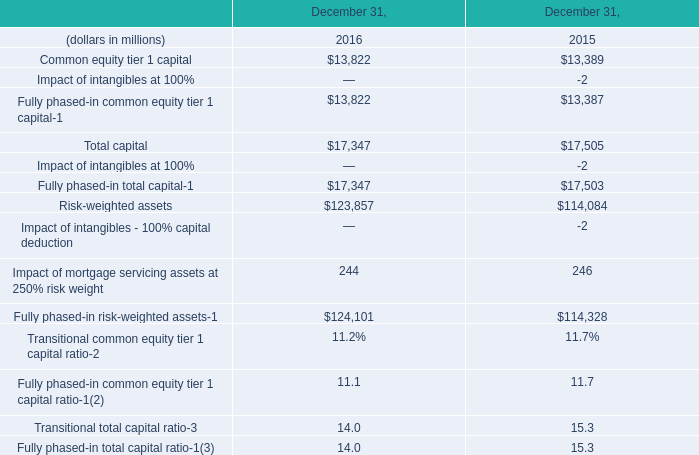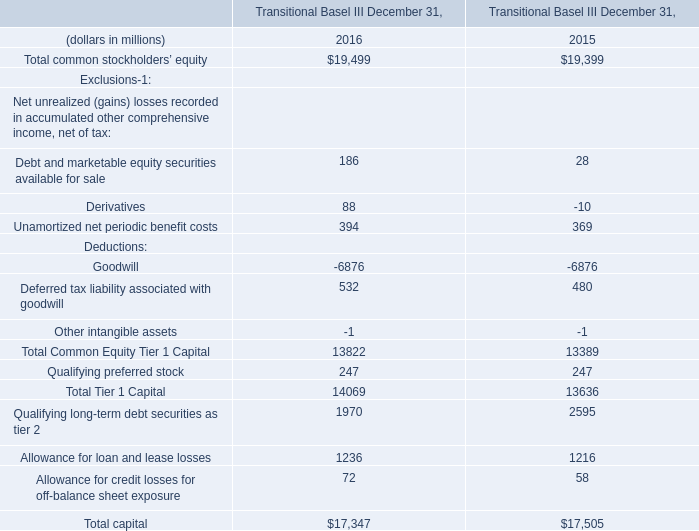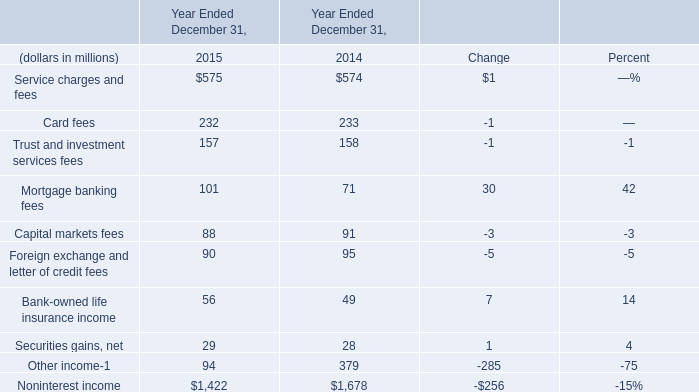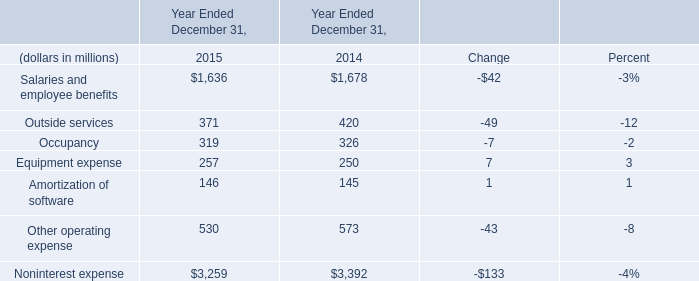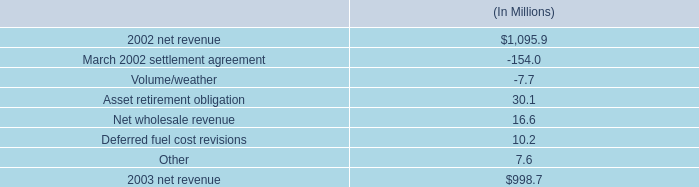what is the percent change in net revenue from 2002 to 2003? 
Computations: ((1095.9 - 998.7) / 998.7)
Answer: 0.09733. 